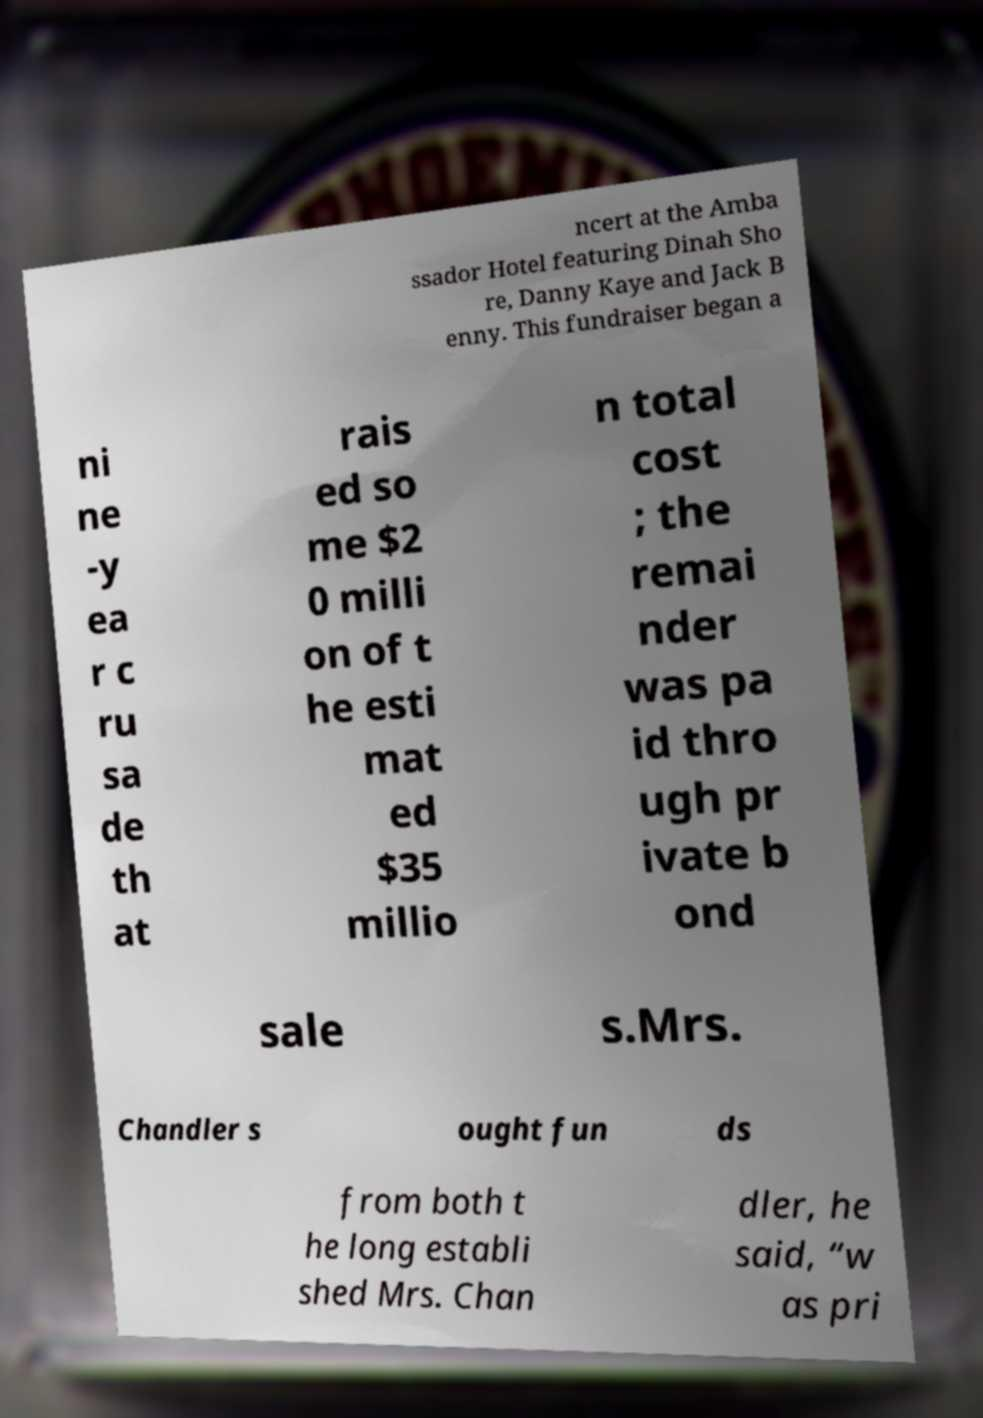Could you extract and type out the text from this image? ncert at the Amba ssador Hotel featuring Dinah Sho re, Danny Kaye and Jack B enny. This fundraiser began a ni ne -y ea r c ru sa de th at rais ed so me $2 0 milli on of t he esti mat ed $35 millio n total cost ; the remai nder was pa id thro ugh pr ivate b ond sale s.Mrs. Chandler s ought fun ds from both t he long establi shed Mrs. Chan dler, he said, “w as pri 